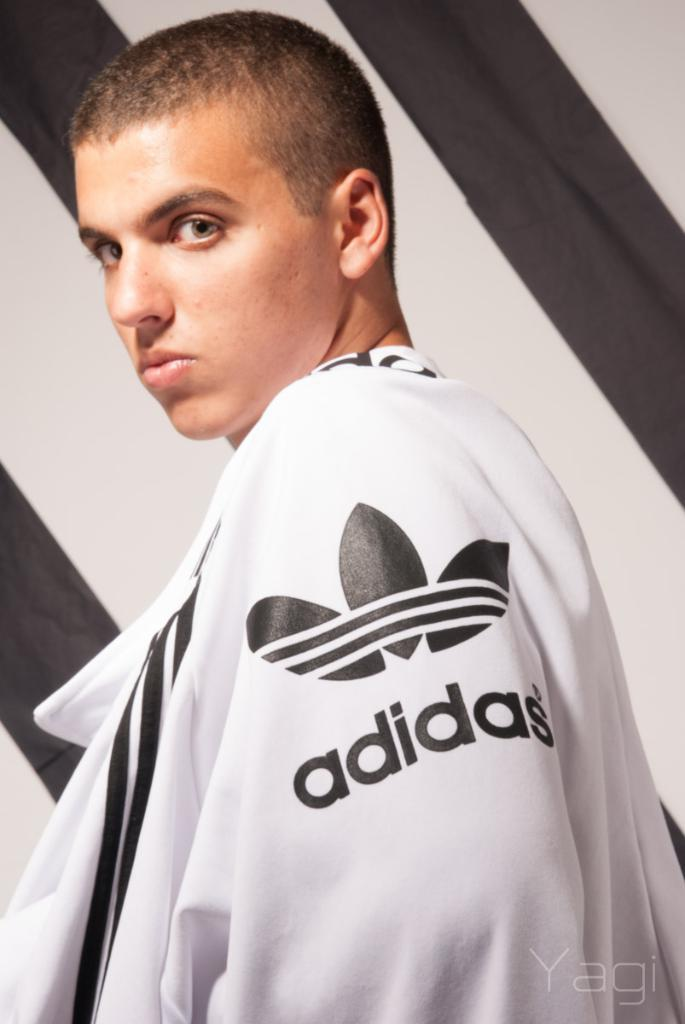<image>
Create a compact narrative representing the image presented. Boy wearing a white sweater that says Adidas. 